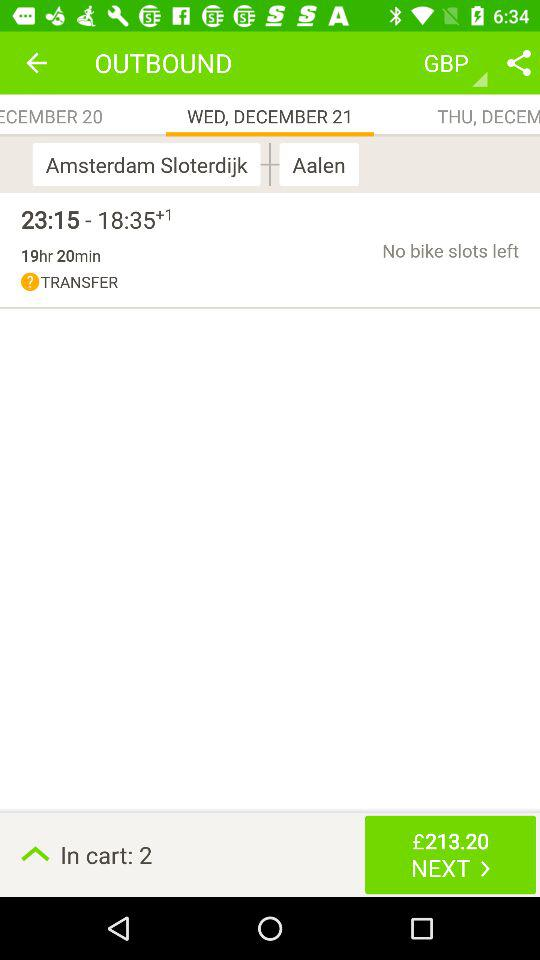How much is the total price of the tickets?
Answer the question using a single word or phrase. £213.20 